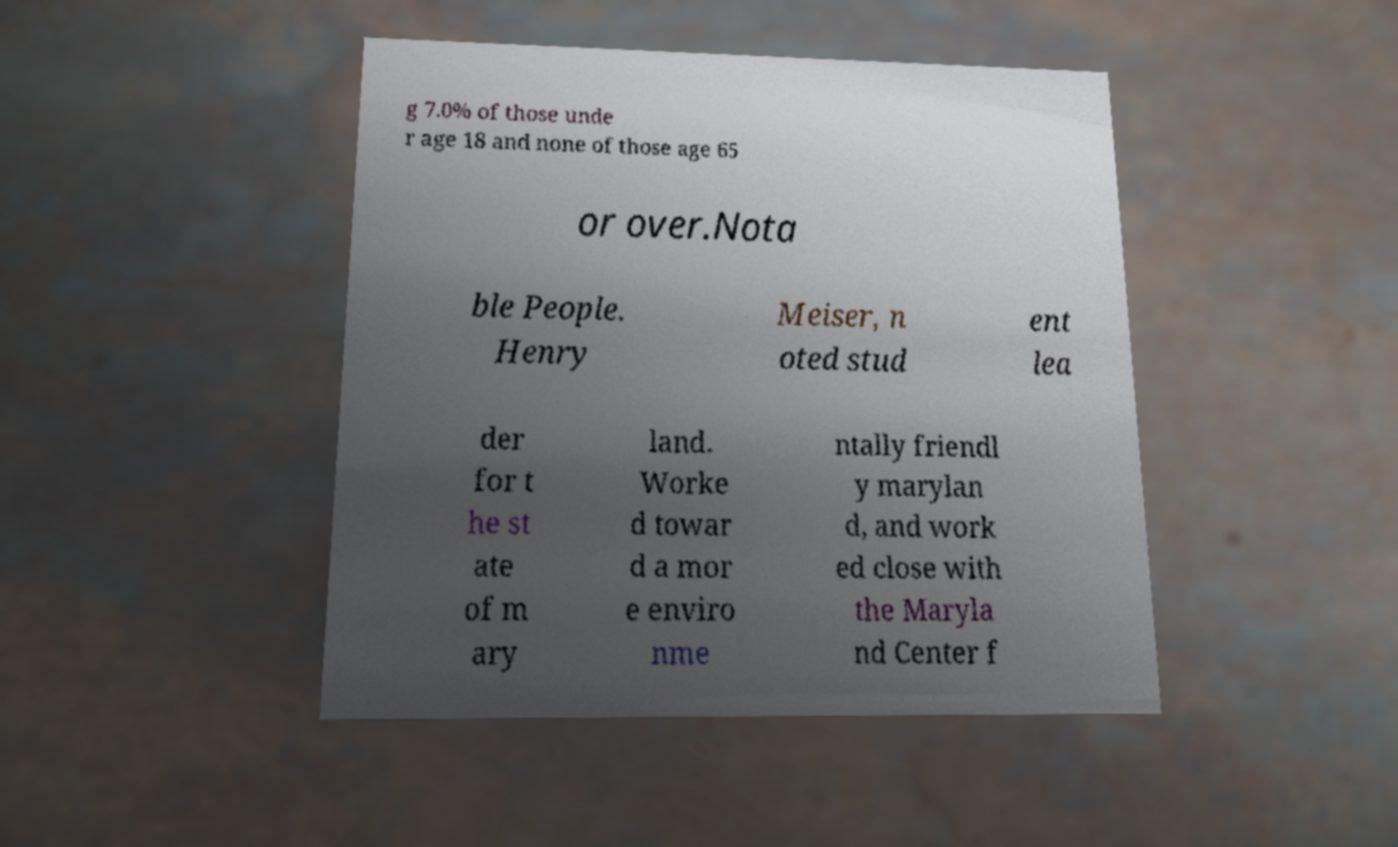Could you assist in decoding the text presented in this image and type it out clearly? g 7.0% of those unde r age 18 and none of those age 65 or over.Nota ble People. Henry Meiser, n oted stud ent lea der for t he st ate of m ary land. Worke d towar d a mor e enviro nme ntally friendl y marylan d, and work ed close with the Maryla nd Center f 